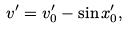Convert formula to latex. <formula><loc_0><loc_0><loc_500><loc_500>v ^ { \prime } = v _ { 0 } ^ { \prime } - \sin x _ { 0 } ^ { \prime } ,</formula> 